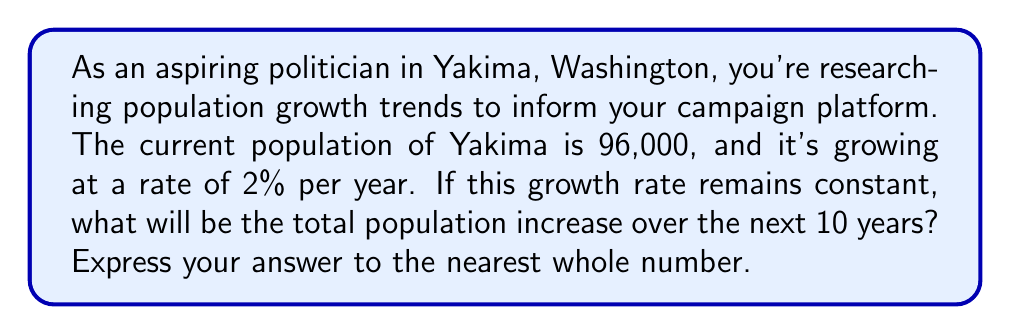Help me with this question. To solve this problem, we need to use the concept of geometric series. Let's break it down step-by-step:

1) First, let's establish our geometric sequence. The initial population is 96,000, and it grows by 2% each year. This means each term in our sequence will be 1.02 times the previous term.

2) Our sequence will look like this:
   $96000, 96000(1.02), 96000(1.02)^2, ..., 96000(1.02)^9$

3) We want to find the sum of the differences between each term and the initial population over 10 years. This can be represented as:

   $S = [96000(1.02) - 96000] + [96000(1.02)^2 - 96000] + ... + [96000(1.02)^{10} - 96000]$

4) This can be simplified to:

   $S = 96000[(1.02 + 1.02^2 + ... + 1.02^{10}) - 10]$

5) The sum in the parentheses is a geometric series with 10 terms, first term $a=1.02$, and common ratio $r=1.02$. We can use the formula for the sum of a geometric series:

   $S_n = \frac{a(1-r^n)}{1-r}$, where $n$ is the number of terms

6) Plugging in our values:

   $S_{10} = \frac{1.02(1-1.02^{10})}{1-1.02} = \frac{1.02(1-1.2189)}{-0.02} = 10.9489$

7) Now we can calculate our total increase:

   $S = 96000(10.9489 - 10) = 96000 * 0.9489 = 91094.4$

8) Rounding to the nearest whole number, we get 91,094.
Answer: 91,094 